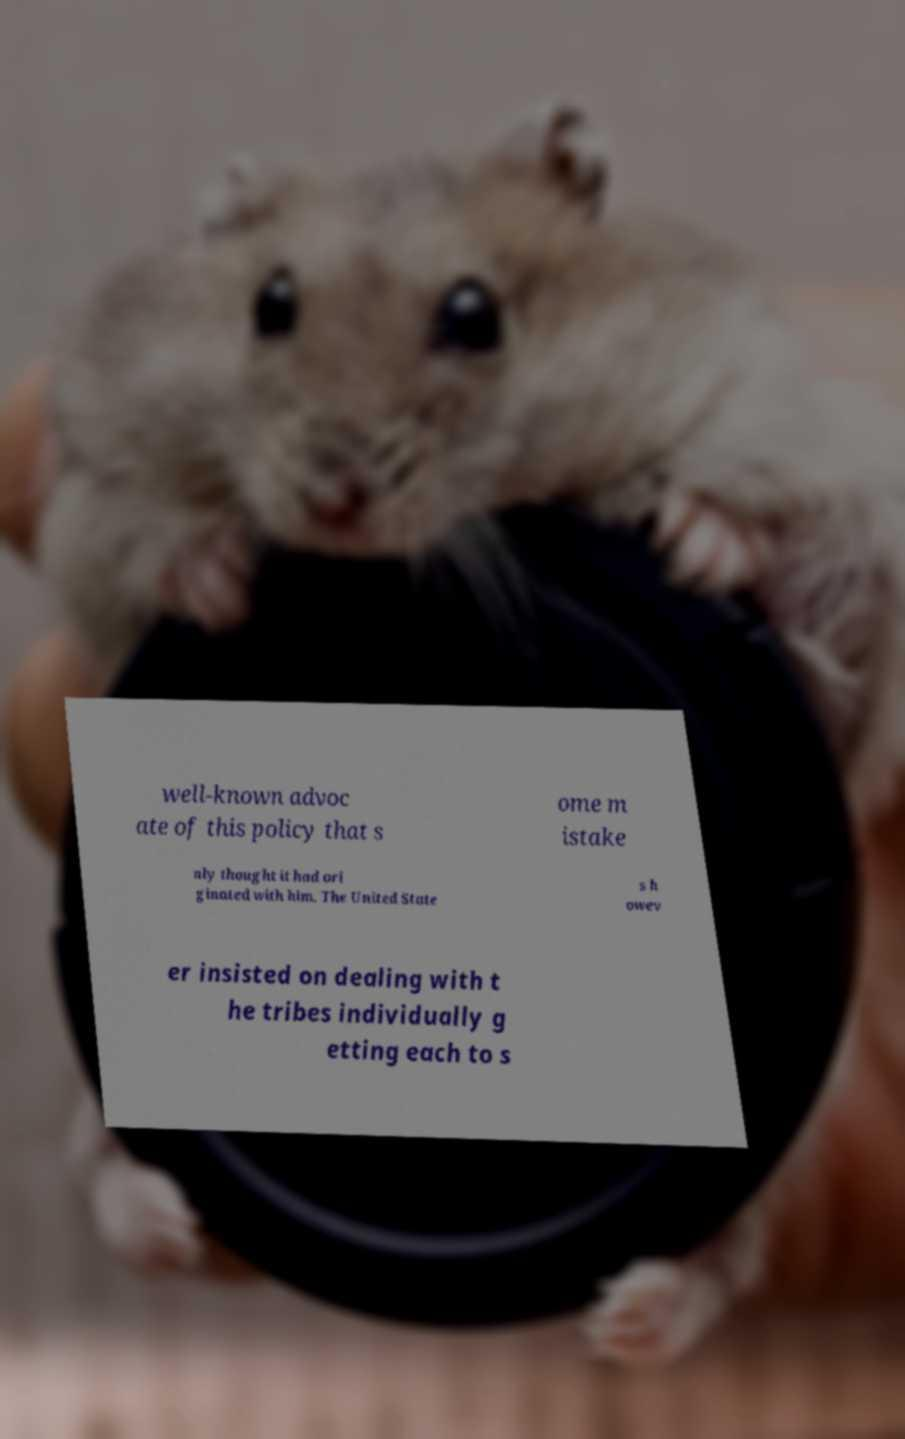Can you accurately transcribe the text from the provided image for me? well-known advoc ate of this policy that s ome m istake nly thought it had ori ginated with him. The United State s h owev er insisted on dealing with t he tribes individually g etting each to s 